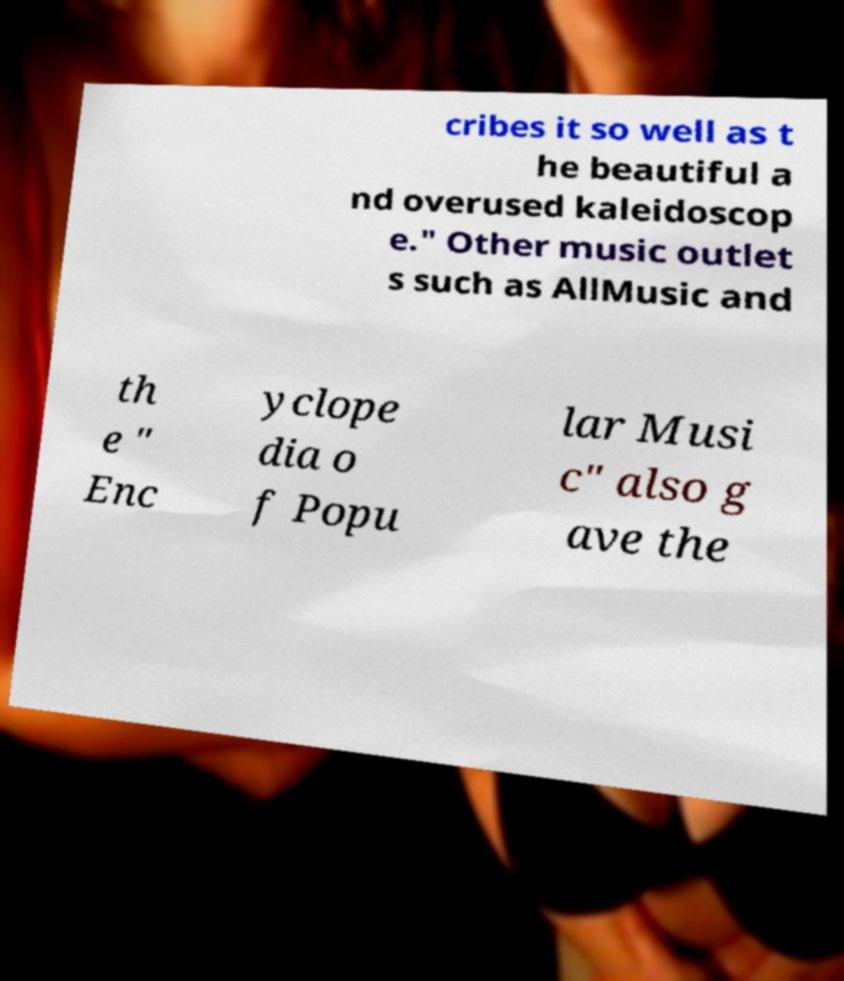Could you extract and type out the text from this image? cribes it so well as t he beautiful a nd overused kaleidoscop e." Other music outlet s such as AllMusic and th e " Enc yclope dia o f Popu lar Musi c" also g ave the 